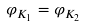<formula> <loc_0><loc_0><loc_500><loc_500>\varphi _ { K _ { 1 } } = \varphi _ { K _ { 2 } }</formula> 